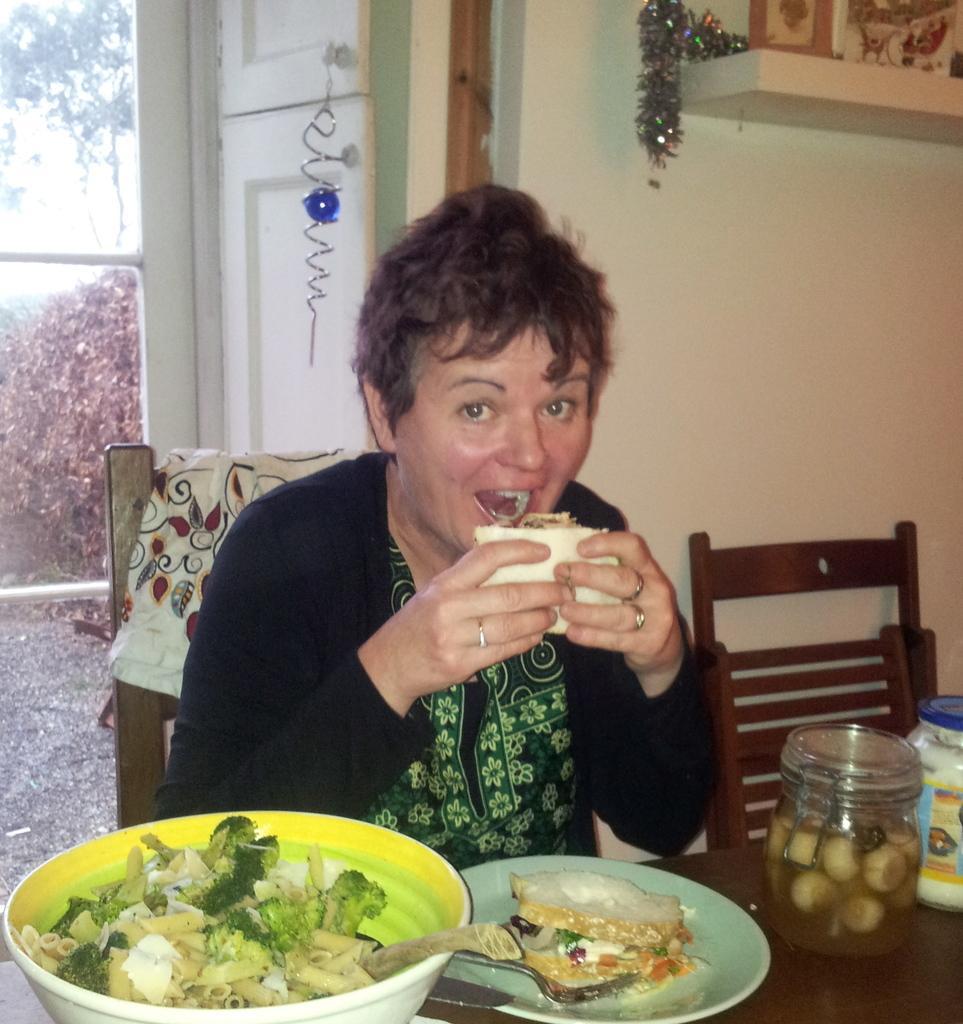Could you give a brief overview of what you see in this image? This picture shows a woman seated on the chair and eating food by holding in her hands and we see a bowl and a plate and a jar and a sauce bottle on the table 